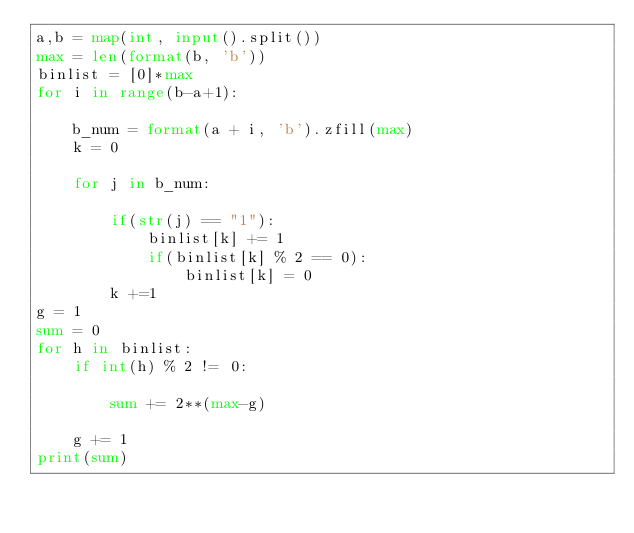<code> <loc_0><loc_0><loc_500><loc_500><_Python_>a,b = map(int, input().split())
max = len(format(b, 'b'))
binlist = [0]*max
for i in range(b-a+1):
    
    b_num = format(a + i, 'b').zfill(max)
    k = 0
 
    for j in b_num:
 
        if(str(j) == "1"):
            binlist[k] += 1
            if(binlist[k] % 2 == 0):
                binlist[k] = 0
        k +=1
g = 1
sum = 0
for h in binlist:
    if int(h) % 2 != 0:
        
        sum += 2**(max-g)
 
    g += 1
print(sum)</code> 